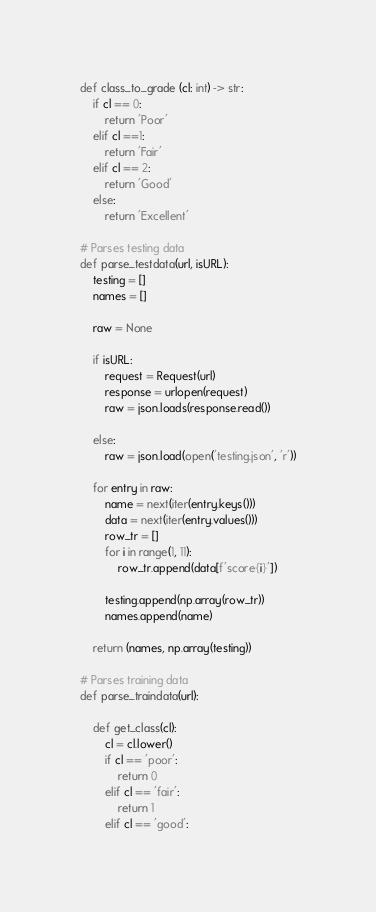Convert code to text. <code><loc_0><loc_0><loc_500><loc_500><_Python_>def class_to_grade (cl: int) -> str:
    if cl == 0:
        return 'Poor'
    elif cl ==1:
        return 'Fair'
    elif cl == 2:
        return 'Good'
    else:
        return 'Excellent'

# Parses testing data
def parse_testdata(url, isURL):
    testing = []
    names = []

    raw = None

    if isURL:
        request = Request(url)
        response = urlopen(request)
        raw = json.loads(response.read())

    else:
        raw = json.load(open('testing.json', 'r'))

    for entry in raw:
        name = next(iter(entry.keys()))
        data = next(iter(entry.values()))
        row_tr = []
        for i in range(1, 11):
            row_tr.append(data[f'score{i}'])

        testing.append(np.array(row_tr))
        names.append(name)

    return (names, np.array(testing))

# Parses training data
def parse_traindata(url):

    def get_class(cl):
        cl = cl.lower()
        if cl == 'poor':
            return 0
        elif cl == 'fair':
            return 1
        elif cl == 'good':</code> 